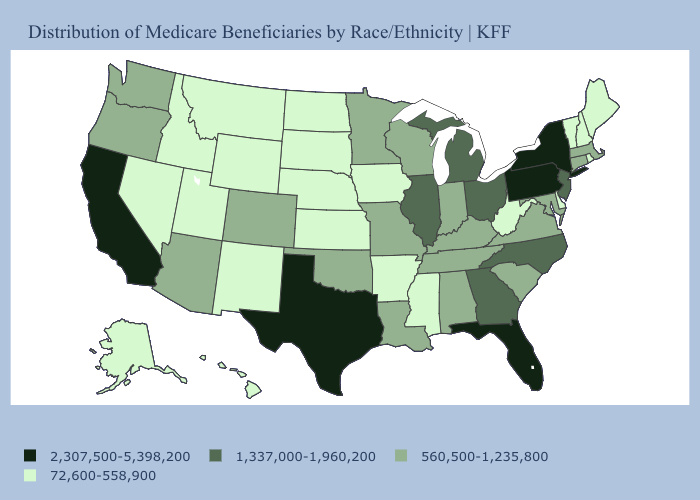What is the value of Kansas?
Keep it brief. 72,600-558,900. Which states hav the highest value in the South?
Keep it brief. Florida, Texas. Does the first symbol in the legend represent the smallest category?
Quick response, please. No. What is the value of Florida?
Concise answer only. 2,307,500-5,398,200. Name the states that have a value in the range 1,337,000-1,960,200?
Keep it brief. Georgia, Illinois, Michigan, New Jersey, North Carolina, Ohio. What is the lowest value in the USA?
Short answer required. 72,600-558,900. Does Vermont have the lowest value in the Northeast?
Write a very short answer. Yes. What is the highest value in the MidWest ?
Short answer required. 1,337,000-1,960,200. Is the legend a continuous bar?
Give a very brief answer. No. What is the value of Utah?
Answer briefly. 72,600-558,900. What is the value of Mississippi?
Be succinct. 72,600-558,900. How many symbols are there in the legend?
Keep it brief. 4. What is the lowest value in states that border Louisiana?
Keep it brief. 72,600-558,900. Among the states that border Indiana , does Ohio have the lowest value?
Quick response, please. No. Does South Dakota have the lowest value in the MidWest?
Short answer required. Yes. 